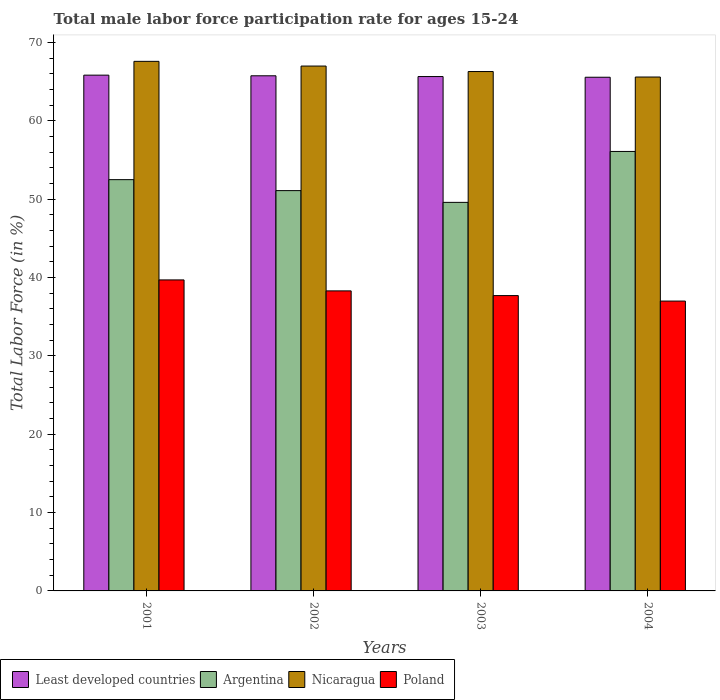Are the number of bars per tick equal to the number of legend labels?
Offer a very short reply. Yes. Are the number of bars on each tick of the X-axis equal?
Provide a short and direct response. Yes. What is the male labor force participation rate in Nicaragua in 2004?
Your answer should be compact. 65.6. Across all years, what is the maximum male labor force participation rate in Nicaragua?
Ensure brevity in your answer.  67.6. Across all years, what is the minimum male labor force participation rate in Poland?
Offer a very short reply. 37. In which year was the male labor force participation rate in Poland maximum?
Provide a short and direct response. 2001. In which year was the male labor force participation rate in Argentina minimum?
Provide a short and direct response. 2003. What is the total male labor force participation rate in Poland in the graph?
Offer a very short reply. 152.7. What is the difference between the male labor force participation rate in Nicaragua in 2001 and that in 2002?
Make the answer very short. 0.6. What is the difference between the male labor force participation rate in Poland in 2003 and the male labor force participation rate in Argentina in 2002?
Your response must be concise. -13.4. What is the average male labor force participation rate in Nicaragua per year?
Offer a very short reply. 66.62. In the year 2002, what is the difference between the male labor force participation rate in Nicaragua and male labor force participation rate in Least developed countries?
Offer a very short reply. 1.24. What is the ratio of the male labor force participation rate in Argentina in 2001 to that in 2004?
Give a very brief answer. 0.94. Is the difference between the male labor force participation rate in Nicaragua in 2001 and 2002 greater than the difference between the male labor force participation rate in Least developed countries in 2001 and 2002?
Provide a succinct answer. Yes. What is the difference between the highest and the second highest male labor force participation rate in Least developed countries?
Keep it short and to the point. 0.08. What is the difference between the highest and the lowest male labor force participation rate in Least developed countries?
Give a very brief answer. 0.27. Is the sum of the male labor force participation rate in Poland in 2001 and 2002 greater than the maximum male labor force participation rate in Argentina across all years?
Your response must be concise. Yes. What does the 1st bar from the left in 2001 represents?
Your answer should be compact. Least developed countries. How many bars are there?
Your response must be concise. 16. Are all the bars in the graph horizontal?
Keep it short and to the point. No. How many years are there in the graph?
Your answer should be very brief. 4. What is the difference between two consecutive major ticks on the Y-axis?
Ensure brevity in your answer.  10. Are the values on the major ticks of Y-axis written in scientific E-notation?
Your response must be concise. No. Does the graph contain any zero values?
Your answer should be very brief. No. Does the graph contain grids?
Your response must be concise. No. Where does the legend appear in the graph?
Provide a succinct answer. Bottom left. What is the title of the graph?
Your response must be concise. Total male labor force participation rate for ages 15-24. What is the label or title of the Y-axis?
Your response must be concise. Total Labor Force (in %). What is the Total Labor Force (in %) of Least developed countries in 2001?
Your answer should be compact. 65.84. What is the Total Labor Force (in %) of Argentina in 2001?
Make the answer very short. 52.5. What is the Total Labor Force (in %) of Nicaragua in 2001?
Provide a short and direct response. 67.6. What is the Total Labor Force (in %) in Poland in 2001?
Offer a very short reply. 39.7. What is the Total Labor Force (in %) in Least developed countries in 2002?
Give a very brief answer. 65.76. What is the Total Labor Force (in %) in Argentina in 2002?
Your answer should be compact. 51.1. What is the Total Labor Force (in %) in Nicaragua in 2002?
Keep it short and to the point. 67. What is the Total Labor Force (in %) in Poland in 2002?
Your answer should be compact. 38.3. What is the Total Labor Force (in %) of Least developed countries in 2003?
Your answer should be very brief. 65.66. What is the Total Labor Force (in %) of Argentina in 2003?
Keep it short and to the point. 49.6. What is the Total Labor Force (in %) of Nicaragua in 2003?
Provide a succinct answer. 66.3. What is the Total Labor Force (in %) in Poland in 2003?
Your answer should be compact. 37.7. What is the Total Labor Force (in %) in Least developed countries in 2004?
Provide a short and direct response. 65.57. What is the Total Labor Force (in %) in Argentina in 2004?
Your response must be concise. 56.1. What is the Total Labor Force (in %) of Nicaragua in 2004?
Make the answer very short. 65.6. Across all years, what is the maximum Total Labor Force (in %) in Least developed countries?
Your response must be concise. 65.84. Across all years, what is the maximum Total Labor Force (in %) in Argentina?
Your answer should be compact. 56.1. Across all years, what is the maximum Total Labor Force (in %) in Nicaragua?
Provide a succinct answer. 67.6. Across all years, what is the maximum Total Labor Force (in %) in Poland?
Offer a very short reply. 39.7. Across all years, what is the minimum Total Labor Force (in %) of Least developed countries?
Your answer should be compact. 65.57. Across all years, what is the minimum Total Labor Force (in %) of Argentina?
Your answer should be compact. 49.6. Across all years, what is the minimum Total Labor Force (in %) of Nicaragua?
Keep it short and to the point. 65.6. What is the total Total Labor Force (in %) in Least developed countries in the graph?
Your answer should be compact. 262.83. What is the total Total Labor Force (in %) of Argentina in the graph?
Give a very brief answer. 209.3. What is the total Total Labor Force (in %) of Nicaragua in the graph?
Keep it short and to the point. 266.5. What is the total Total Labor Force (in %) of Poland in the graph?
Give a very brief answer. 152.7. What is the difference between the Total Labor Force (in %) in Least developed countries in 2001 and that in 2002?
Ensure brevity in your answer.  0.08. What is the difference between the Total Labor Force (in %) of Argentina in 2001 and that in 2002?
Keep it short and to the point. 1.4. What is the difference between the Total Labor Force (in %) in Nicaragua in 2001 and that in 2002?
Keep it short and to the point. 0.6. What is the difference between the Total Labor Force (in %) of Poland in 2001 and that in 2002?
Keep it short and to the point. 1.4. What is the difference between the Total Labor Force (in %) in Least developed countries in 2001 and that in 2003?
Ensure brevity in your answer.  0.18. What is the difference between the Total Labor Force (in %) of Argentina in 2001 and that in 2003?
Offer a very short reply. 2.9. What is the difference between the Total Labor Force (in %) in Least developed countries in 2001 and that in 2004?
Ensure brevity in your answer.  0.27. What is the difference between the Total Labor Force (in %) in Least developed countries in 2002 and that in 2003?
Keep it short and to the point. 0.1. What is the difference between the Total Labor Force (in %) in Argentina in 2002 and that in 2003?
Your response must be concise. 1.5. What is the difference between the Total Labor Force (in %) in Nicaragua in 2002 and that in 2003?
Keep it short and to the point. 0.7. What is the difference between the Total Labor Force (in %) of Poland in 2002 and that in 2003?
Offer a terse response. 0.6. What is the difference between the Total Labor Force (in %) in Least developed countries in 2002 and that in 2004?
Ensure brevity in your answer.  0.19. What is the difference between the Total Labor Force (in %) in Least developed countries in 2003 and that in 2004?
Make the answer very short. 0.09. What is the difference between the Total Labor Force (in %) of Nicaragua in 2003 and that in 2004?
Your answer should be compact. 0.7. What is the difference between the Total Labor Force (in %) of Least developed countries in 2001 and the Total Labor Force (in %) of Argentina in 2002?
Ensure brevity in your answer.  14.74. What is the difference between the Total Labor Force (in %) in Least developed countries in 2001 and the Total Labor Force (in %) in Nicaragua in 2002?
Ensure brevity in your answer.  -1.16. What is the difference between the Total Labor Force (in %) of Least developed countries in 2001 and the Total Labor Force (in %) of Poland in 2002?
Provide a succinct answer. 27.54. What is the difference between the Total Labor Force (in %) of Nicaragua in 2001 and the Total Labor Force (in %) of Poland in 2002?
Provide a short and direct response. 29.3. What is the difference between the Total Labor Force (in %) in Least developed countries in 2001 and the Total Labor Force (in %) in Argentina in 2003?
Provide a short and direct response. 16.24. What is the difference between the Total Labor Force (in %) of Least developed countries in 2001 and the Total Labor Force (in %) of Nicaragua in 2003?
Provide a short and direct response. -0.46. What is the difference between the Total Labor Force (in %) of Least developed countries in 2001 and the Total Labor Force (in %) of Poland in 2003?
Your response must be concise. 28.14. What is the difference between the Total Labor Force (in %) in Argentina in 2001 and the Total Labor Force (in %) in Nicaragua in 2003?
Provide a succinct answer. -13.8. What is the difference between the Total Labor Force (in %) in Nicaragua in 2001 and the Total Labor Force (in %) in Poland in 2003?
Provide a succinct answer. 29.9. What is the difference between the Total Labor Force (in %) in Least developed countries in 2001 and the Total Labor Force (in %) in Argentina in 2004?
Your answer should be compact. 9.74. What is the difference between the Total Labor Force (in %) of Least developed countries in 2001 and the Total Labor Force (in %) of Nicaragua in 2004?
Your answer should be very brief. 0.24. What is the difference between the Total Labor Force (in %) of Least developed countries in 2001 and the Total Labor Force (in %) of Poland in 2004?
Make the answer very short. 28.84. What is the difference between the Total Labor Force (in %) in Argentina in 2001 and the Total Labor Force (in %) in Nicaragua in 2004?
Give a very brief answer. -13.1. What is the difference between the Total Labor Force (in %) of Argentina in 2001 and the Total Labor Force (in %) of Poland in 2004?
Give a very brief answer. 15.5. What is the difference between the Total Labor Force (in %) in Nicaragua in 2001 and the Total Labor Force (in %) in Poland in 2004?
Offer a very short reply. 30.6. What is the difference between the Total Labor Force (in %) in Least developed countries in 2002 and the Total Labor Force (in %) in Argentina in 2003?
Your answer should be very brief. 16.16. What is the difference between the Total Labor Force (in %) of Least developed countries in 2002 and the Total Labor Force (in %) of Nicaragua in 2003?
Your response must be concise. -0.54. What is the difference between the Total Labor Force (in %) in Least developed countries in 2002 and the Total Labor Force (in %) in Poland in 2003?
Give a very brief answer. 28.06. What is the difference between the Total Labor Force (in %) of Argentina in 2002 and the Total Labor Force (in %) of Nicaragua in 2003?
Provide a succinct answer. -15.2. What is the difference between the Total Labor Force (in %) in Argentina in 2002 and the Total Labor Force (in %) in Poland in 2003?
Your response must be concise. 13.4. What is the difference between the Total Labor Force (in %) of Nicaragua in 2002 and the Total Labor Force (in %) of Poland in 2003?
Keep it short and to the point. 29.3. What is the difference between the Total Labor Force (in %) in Least developed countries in 2002 and the Total Labor Force (in %) in Argentina in 2004?
Keep it short and to the point. 9.66. What is the difference between the Total Labor Force (in %) in Least developed countries in 2002 and the Total Labor Force (in %) in Nicaragua in 2004?
Provide a succinct answer. 0.16. What is the difference between the Total Labor Force (in %) of Least developed countries in 2002 and the Total Labor Force (in %) of Poland in 2004?
Your response must be concise. 28.76. What is the difference between the Total Labor Force (in %) in Argentina in 2002 and the Total Labor Force (in %) in Poland in 2004?
Your answer should be compact. 14.1. What is the difference between the Total Labor Force (in %) in Nicaragua in 2002 and the Total Labor Force (in %) in Poland in 2004?
Your answer should be compact. 30. What is the difference between the Total Labor Force (in %) in Least developed countries in 2003 and the Total Labor Force (in %) in Argentina in 2004?
Your answer should be very brief. 9.56. What is the difference between the Total Labor Force (in %) in Least developed countries in 2003 and the Total Labor Force (in %) in Nicaragua in 2004?
Your answer should be compact. 0.06. What is the difference between the Total Labor Force (in %) of Least developed countries in 2003 and the Total Labor Force (in %) of Poland in 2004?
Offer a very short reply. 28.66. What is the difference between the Total Labor Force (in %) in Argentina in 2003 and the Total Labor Force (in %) in Poland in 2004?
Your answer should be very brief. 12.6. What is the difference between the Total Labor Force (in %) in Nicaragua in 2003 and the Total Labor Force (in %) in Poland in 2004?
Offer a terse response. 29.3. What is the average Total Labor Force (in %) in Least developed countries per year?
Give a very brief answer. 65.71. What is the average Total Labor Force (in %) of Argentina per year?
Offer a very short reply. 52.33. What is the average Total Labor Force (in %) in Nicaragua per year?
Make the answer very short. 66.62. What is the average Total Labor Force (in %) of Poland per year?
Provide a succinct answer. 38.17. In the year 2001, what is the difference between the Total Labor Force (in %) in Least developed countries and Total Labor Force (in %) in Argentina?
Make the answer very short. 13.34. In the year 2001, what is the difference between the Total Labor Force (in %) of Least developed countries and Total Labor Force (in %) of Nicaragua?
Make the answer very short. -1.76. In the year 2001, what is the difference between the Total Labor Force (in %) in Least developed countries and Total Labor Force (in %) in Poland?
Offer a terse response. 26.14. In the year 2001, what is the difference between the Total Labor Force (in %) of Argentina and Total Labor Force (in %) of Nicaragua?
Make the answer very short. -15.1. In the year 2001, what is the difference between the Total Labor Force (in %) in Argentina and Total Labor Force (in %) in Poland?
Provide a succinct answer. 12.8. In the year 2001, what is the difference between the Total Labor Force (in %) of Nicaragua and Total Labor Force (in %) of Poland?
Give a very brief answer. 27.9. In the year 2002, what is the difference between the Total Labor Force (in %) in Least developed countries and Total Labor Force (in %) in Argentina?
Offer a very short reply. 14.66. In the year 2002, what is the difference between the Total Labor Force (in %) of Least developed countries and Total Labor Force (in %) of Nicaragua?
Your response must be concise. -1.24. In the year 2002, what is the difference between the Total Labor Force (in %) of Least developed countries and Total Labor Force (in %) of Poland?
Make the answer very short. 27.46. In the year 2002, what is the difference between the Total Labor Force (in %) of Argentina and Total Labor Force (in %) of Nicaragua?
Keep it short and to the point. -15.9. In the year 2002, what is the difference between the Total Labor Force (in %) of Nicaragua and Total Labor Force (in %) of Poland?
Keep it short and to the point. 28.7. In the year 2003, what is the difference between the Total Labor Force (in %) of Least developed countries and Total Labor Force (in %) of Argentina?
Give a very brief answer. 16.06. In the year 2003, what is the difference between the Total Labor Force (in %) in Least developed countries and Total Labor Force (in %) in Nicaragua?
Your answer should be very brief. -0.64. In the year 2003, what is the difference between the Total Labor Force (in %) of Least developed countries and Total Labor Force (in %) of Poland?
Your answer should be compact. 27.96. In the year 2003, what is the difference between the Total Labor Force (in %) of Argentina and Total Labor Force (in %) of Nicaragua?
Make the answer very short. -16.7. In the year 2003, what is the difference between the Total Labor Force (in %) of Nicaragua and Total Labor Force (in %) of Poland?
Ensure brevity in your answer.  28.6. In the year 2004, what is the difference between the Total Labor Force (in %) of Least developed countries and Total Labor Force (in %) of Argentina?
Your answer should be very brief. 9.47. In the year 2004, what is the difference between the Total Labor Force (in %) of Least developed countries and Total Labor Force (in %) of Nicaragua?
Give a very brief answer. -0.03. In the year 2004, what is the difference between the Total Labor Force (in %) of Least developed countries and Total Labor Force (in %) of Poland?
Provide a succinct answer. 28.57. In the year 2004, what is the difference between the Total Labor Force (in %) in Argentina and Total Labor Force (in %) in Poland?
Your answer should be very brief. 19.1. In the year 2004, what is the difference between the Total Labor Force (in %) of Nicaragua and Total Labor Force (in %) of Poland?
Your response must be concise. 28.6. What is the ratio of the Total Labor Force (in %) in Least developed countries in 2001 to that in 2002?
Provide a succinct answer. 1. What is the ratio of the Total Labor Force (in %) in Argentina in 2001 to that in 2002?
Your response must be concise. 1.03. What is the ratio of the Total Labor Force (in %) in Poland in 2001 to that in 2002?
Keep it short and to the point. 1.04. What is the ratio of the Total Labor Force (in %) in Argentina in 2001 to that in 2003?
Make the answer very short. 1.06. What is the ratio of the Total Labor Force (in %) of Nicaragua in 2001 to that in 2003?
Your response must be concise. 1.02. What is the ratio of the Total Labor Force (in %) in Poland in 2001 to that in 2003?
Your answer should be very brief. 1.05. What is the ratio of the Total Labor Force (in %) in Argentina in 2001 to that in 2004?
Your answer should be compact. 0.94. What is the ratio of the Total Labor Force (in %) in Nicaragua in 2001 to that in 2004?
Ensure brevity in your answer.  1.03. What is the ratio of the Total Labor Force (in %) in Poland in 2001 to that in 2004?
Make the answer very short. 1.07. What is the ratio of the Total Labor Force (in %) of Argentina in 2002 to that in 2003?
Keep it short and to the point. 1.03. What is the ratio of the Total Labor Force (in %) in Nicaragua in 2002 to that in 2003?
Provide a short and direct response. 1.01. What is the ratio of the Total Labor Force (in %) of Poland in 2002 to that in 2003?
Your response must be concise. 1.02. What is the ratio of the Total Labor Force (in %) in Argentina in 2002 to that in 2004?
Your answer should be compact. 0.91. What is the ratio of the Total Labor Force (in %) of Nicaragua in 2002 to that in 2004?
Give a very brief answer. 1.02. What is the ratio of the Total Labor Force (in %) of Poland in 2002 to that in 2004?
Your answer should be compact. 1.04. What is the ratio of the Total Labor Force (in %) in Argentina in 2003 to that in 2004?
Your answer should be very brief. 0.88. What is the ratio of the Total Labor Force (in %) of Nicaragua in 2003 to that in 2004?
Give a very brief answer. 1.01. What is the ratio of the Total Labor Force (in %) in Poland in 2003 to that in 2004?
Your answer should be very brief. 1.02. What is the difference between the highest and the second highest Total Labor Force (in %) in Least developed countries?
Your answer should be very brief. 0.08. What is the difference between the highest and the lowest Total Labor Force (in %) of Least developed countries?
Your response must be concise. 0.27. What is the difference between the highest and the lowest Total Labor Force (in %) in Poland?
Provide a short and direct response. 2.7. 